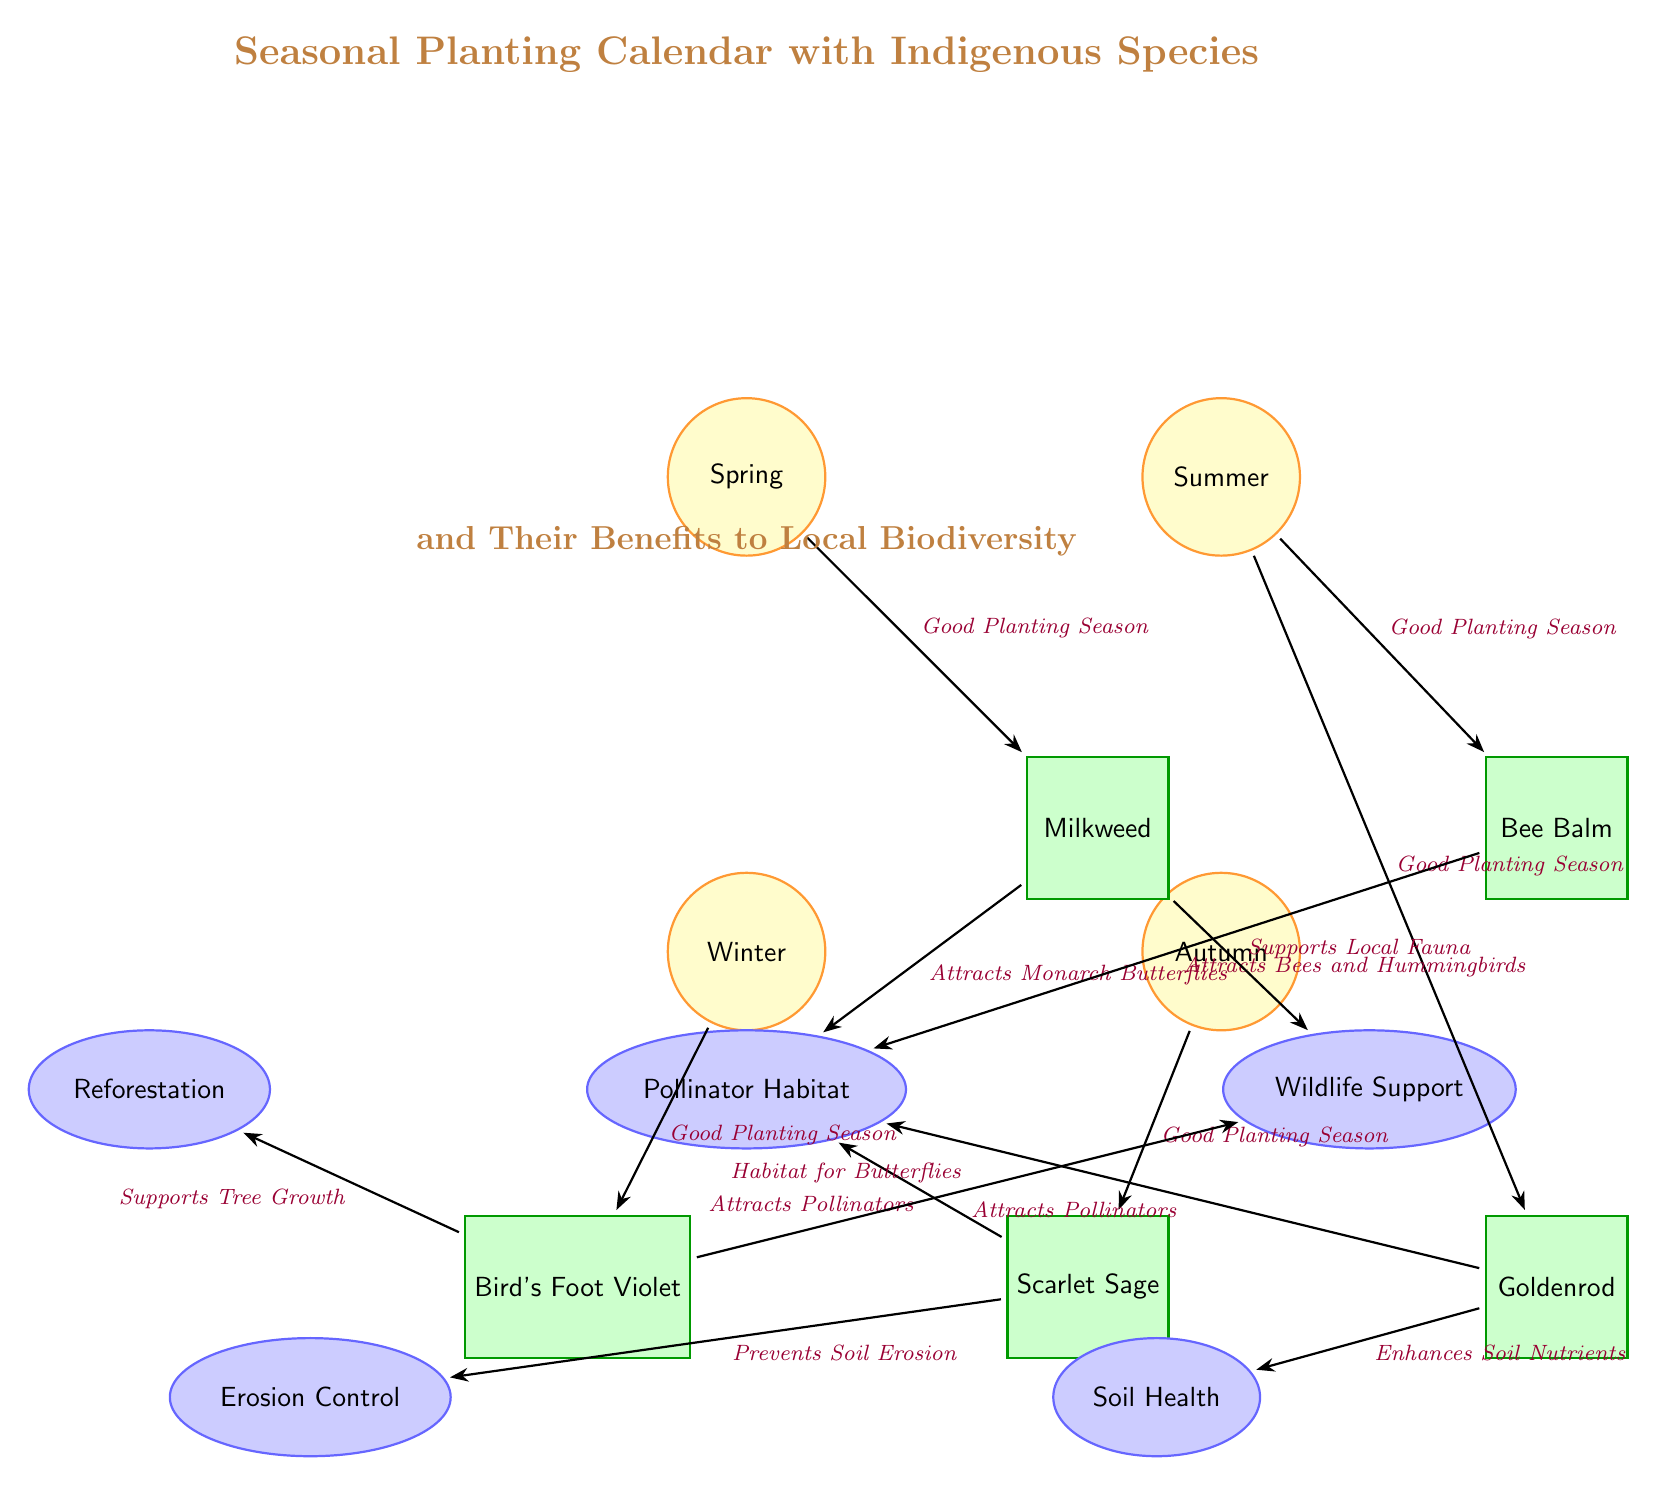What is the planting season for Milkweed? The diagram indicates that Milkweed is planted during the Spring season, as denoted by the edge connecting Milkweed to the Spring node.
Answer: Spring How many indigenous species are listed in the diagram? The diagram features five indigenous species: Milkweed, Bee Balm, Goldenrod, Scarlet Sage, and Bird's Foot Violet. Counting these nodes gives a total of five species.
Answer: 5 Which plant is associated with attracting Bees and Hummingbirds? The edge connecting Bee Balm to the Pollinator Habitat specifies that Bee Balm attracts Bees and Hummingbirds.
Answer: Bee Balm What benefit is specifically linked to Scarlet Sage? According to the diagram, Scarlet Sage is noted for its role in preventing soil erosion, as indicated by the edge connecting it to the Erosion Control benefit.
Answer: Erosion Control Which two plants enhance soil health and attract pollinators? The diagram shows that both Goldenrod enhances soil nutrients and attracts pollinators, while Milkweed and Scarlet Sage are also linked to attracting pollinators. By focusing on benefits, the answer is Goldenrod for soil health, while Milkweed and Scarlet Sage are for attracting pollinators.
Answer: Goldenrod; Milkweed and Scarlet Sage What is the relationship between Bird's Foot Violet and Wildlife Support? The diagram connects Bird's Foot Violet to the Wildlife Support benefit, indicating that Bird's Foot Violet provides habitat for butterflies, thus supporting local wildlife directly.
Answer: Habitat for Butterflies In which season is Scarlet Sage planted? Scarlet Sage is planted during the Autumn season, as shown by the edge connecting Scarlet Sage to the Autumn season node.
Answer: Autumn How many benefits are associated with the plants in the diagram? The diagram lists five benefits: Pollinator Habitat, Wildlife Support, Soil Health, Erosion Control, and Reforestation, hence there are five benefits associated with the plants.
Answer: 5 Which plant supports tree growth? Bird's Foot Violet is linked to the benefit of reforestation, indicating that it supports tree growth, as detailed by the edge from Bird's Foot Violet to the Reforestation benefit.
Answer: Bird's Foot Violet What is the planting season for Goldenrod? Goldenrod is indicated to be planted in the Summer season, based on the edge showing the connection between Goldenrod and the Summer node.
Answer: Summer 